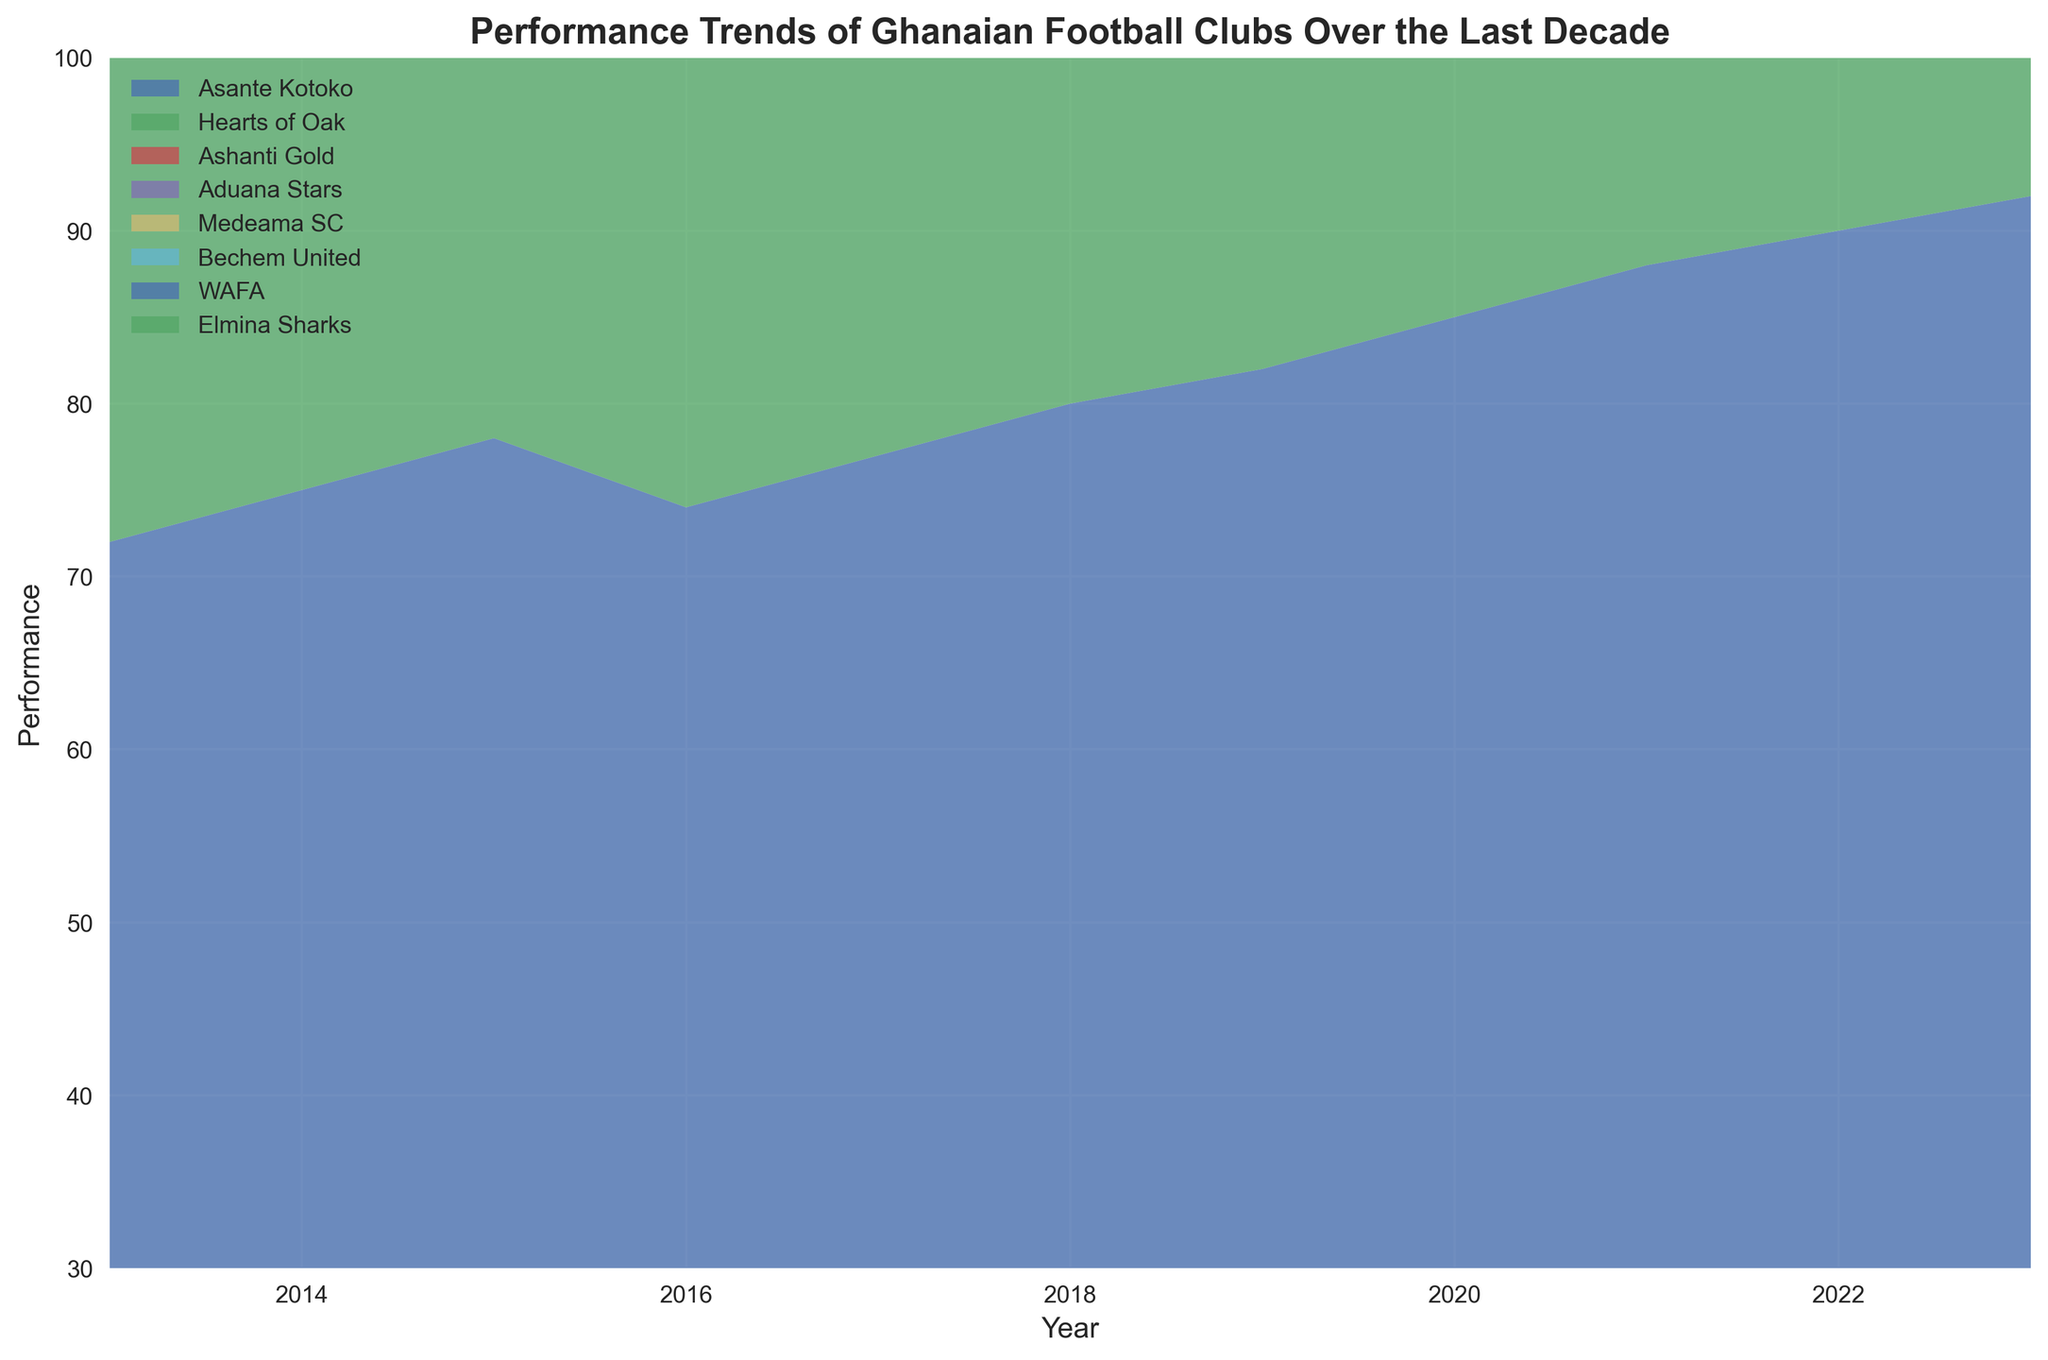Which team shows the most consistent increase in performance over the decade? Hearts of Oak shows a steady increase in performance each year without any significant dips, indicating consistency.
Answer: Hearts of Oak Which team had the highest performance in 2020? Asante Kotoko had the highest performance in 2020, as its area at the top of the chart is the largest in that year.
Answer: Asante Kotoko By how many points did Medeama SC’s performance increase from 2015 to 2020? Medeama SC's performance was 55 in 2015 and increased to 65 in 2020. The difference is 65 - 55.
Answer: 10 points Which team had the biggest performance drop from one year to the next? Asante Kotoko shows a drop from 78 in 2015 to 74 in 2016. The difference is -4, the largest single-year drop visible.
Answer: Asante Kotoko Which two teams had equal performance in the year 2020? In the year 2020, Aduana Stars and Bechem United share the same color segment level at about 69 points.
Answer: None Between WAFA and Elmina Sharks, which team improved more from 2013 to 2023? WAFA improved from 40 in 2013 to 63 in 2023, an increase of 23 points, while Elmina Sharks improved from 35 in 2013 to 57 in 2023, an increase of 22 points.
Answer: WAFA In 2018, which team had a performance closest to the midpoint of the range (30 to 100)? In 2018, Bechem United had a performance of 55, which is closest to the midpoint (65).
Answer: Bechem United Comparing Aduana Stars' performance in 2019 and 2023, did the team improve or decline? By how much? Aduana Stars had a performance of 66 in 2019 and 76 in 2023. The difference is 76 - 66, indicating an improvement.
Answer: Improved by 10 points Which team had its peak performance in 2023? All teams had their peak performance in 2023 as the data keeps increasing every year. Therefore, Asante Kotoko had the highest peak in 2023 with 92 points.
Answer: Asante Kotoko 